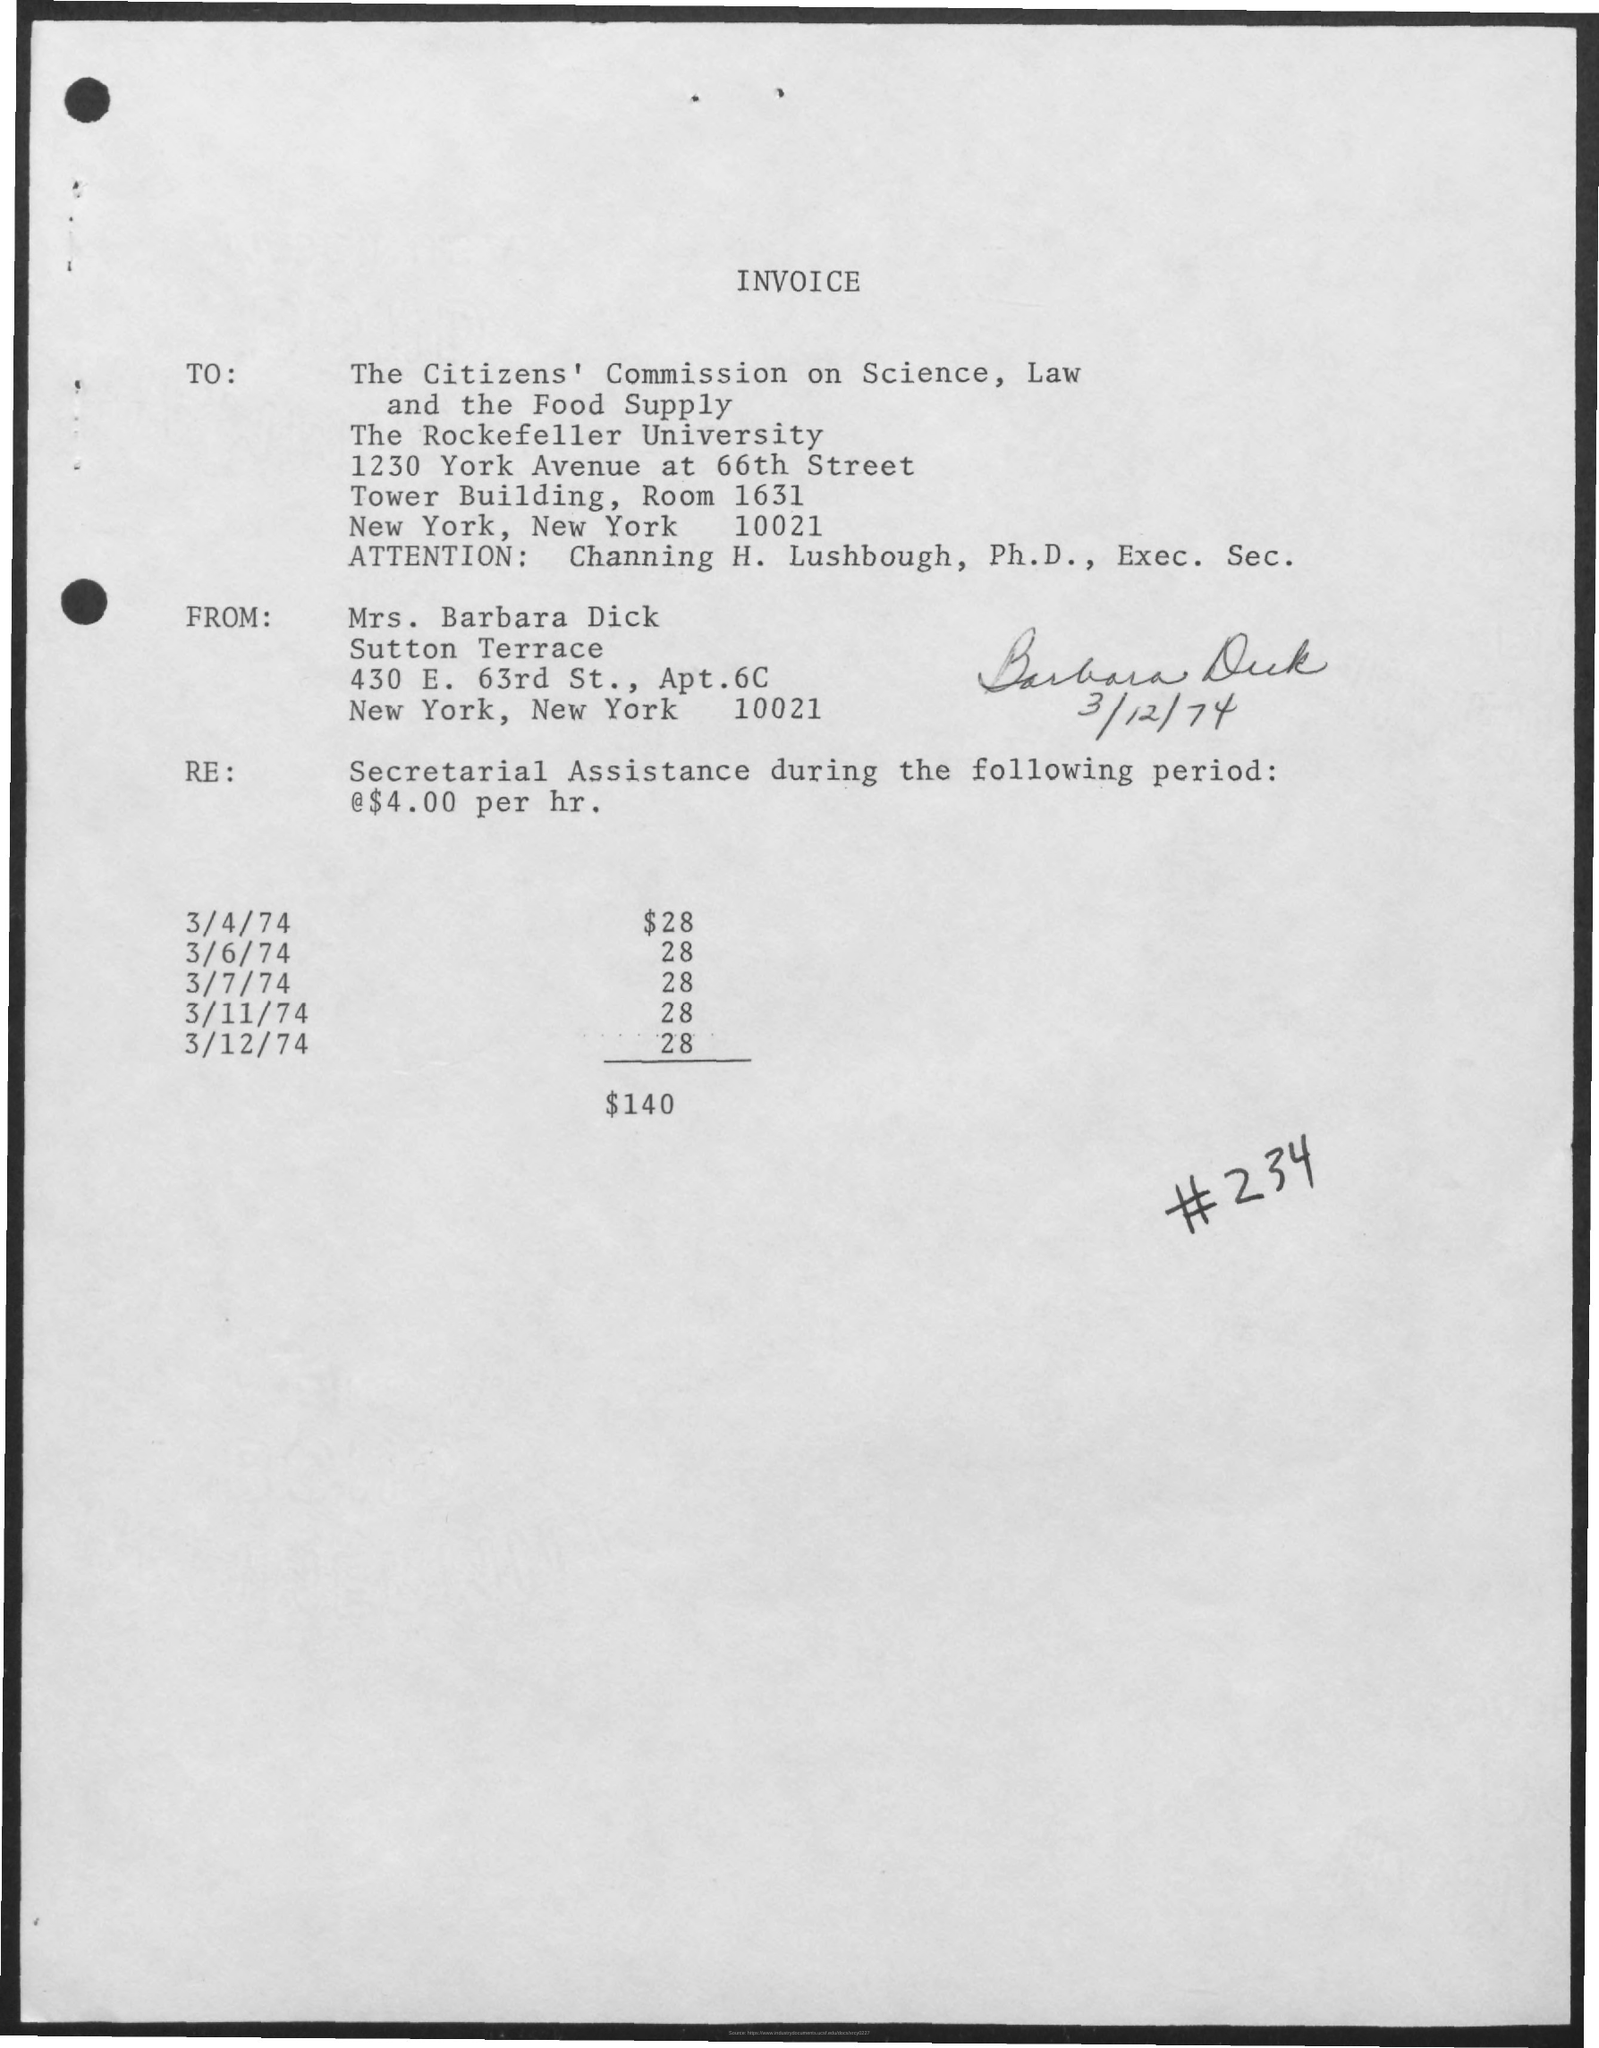Who is the sender of this invoice?
Keep it short and to the point. Mrs. Barbara Dick. To whom, the invoice is addressed?
Your answer should be compact. The Citizens' Commission on Science, Law and the Food Supply. What is the  total amount of invoice given?
Offer a very short reply. $140. 